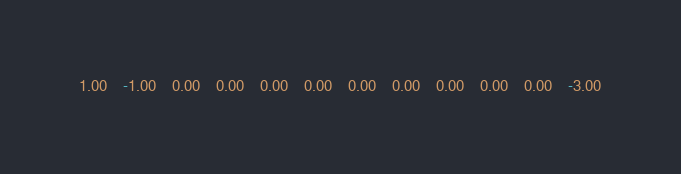Convert code to text. <code><loc_0><loc_0><loc_500><loc_500><_Matlab_>1.00	-1.00	0.00	0.00	0.00	0.00	0.00	0.00	0.00	0.00	0.00	-3.00</code> 